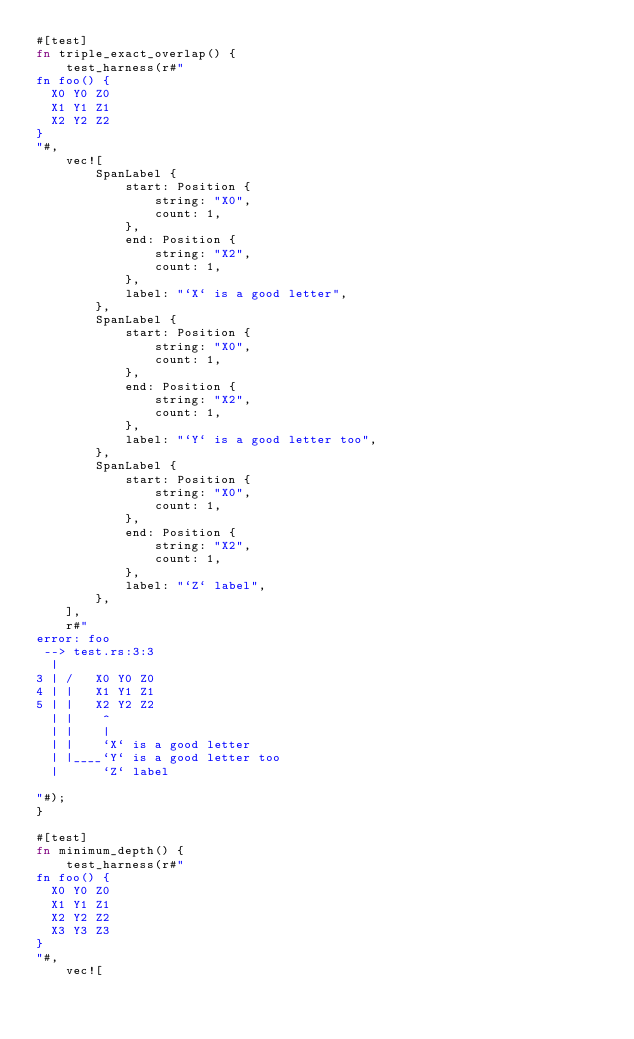Convert code to text. <code><loc_0><loc_0><loc_500><loc_500><_Rust_>#[test]
fn triple_exact_overlap() {
    test_harness(r#"
fn foo() {
  X0 Y0 Z0
  X1 Y1 Z1
  X2 Y2 Z2
}
"#,
    vec![
        SpanLabel {
            start: Position {
                string: "X0",
                count: 1,
            },
            end: Position {
                string: "X2",
                count: 1,
            },
            label: "`X` is a good letter",
        },
        SpanLabel {
            start: Position {
                string: "X0",
                count: 1,
            },
            end: Position {
                string: "X2",
                count: 1,
            },
            label: "`Y` is a good letter too",
        },
        SpanLabel {
            start: Position {
                string: "X0",
                count: 1,
            },
            end: Position {
                string: "X2",
                count: 1,
            },
            label: "`Z` label",
        },
    ],
    r#"
error: foo
 --> test.rs:3:3
  |
3 | /   X0 Y0 Z0
4 | |   X1 Y1 Z1
5 | |   X2 Y2 Z2
  | |    ^
  | |    |
  | |    `X` is a good letter
  | |____`Y` is a good letter too
  |      `Z` label

"#);
}

#[test]
fn minimum_depth() {
    test_harness(r#"
fn foo() {
  X0 Y0 Z0
  X1 Y1 Z1
  X2 Y2 Z2
  X3 Y3 Z3
}
"#,
    vec![</code> 